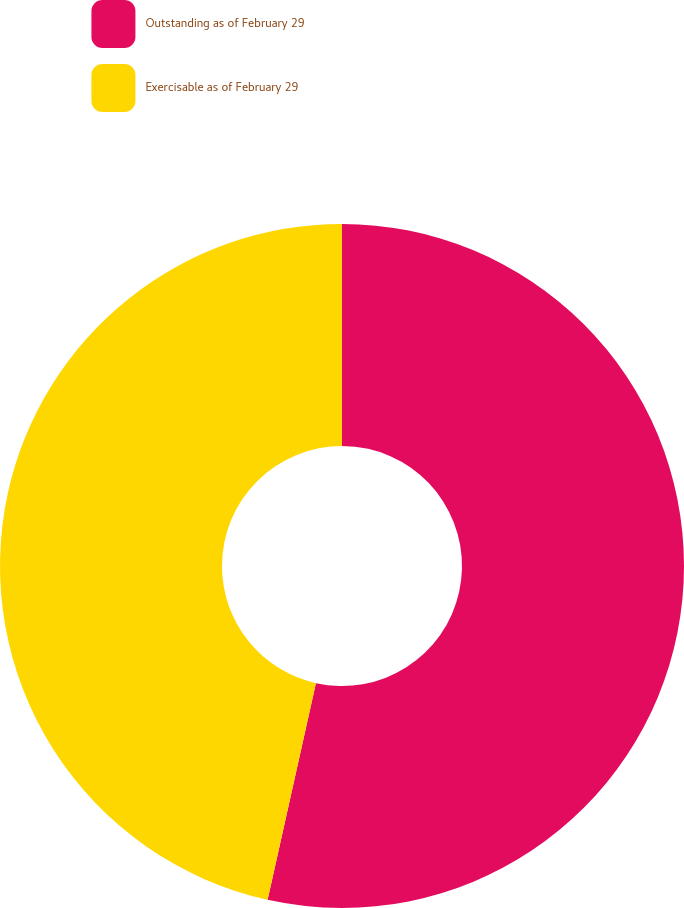<chart> <loc_0><loc_0><loc_500><loc_500><pie_chart><fcel>Outstanding as of February 29<fcel>Exercisable as of February 29<nl><fcel>53.49%<fcel>46.51%<nl></chart> 